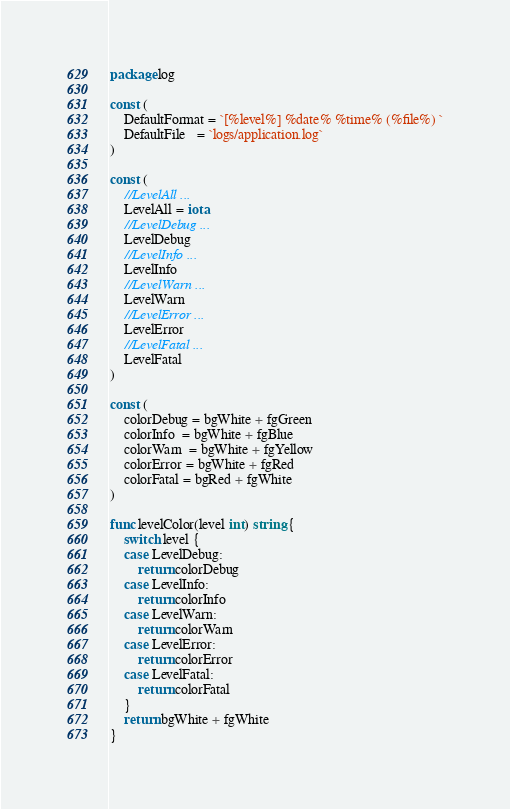Convert code to text. <code><loc_0><loc_0><loc_500><loc_500><_Go_>package log

const (
	DefaultFormat = `[%level%] %date% %time% (%file%) `
	DefaultFile   = `logs/application.log`
)

const (
	//LevelAll ...
	LevelAll = iota
	//LevelDebug ...
	LevelDebug
	//LevelInfo ...
	LevelInfo
	//LevelWarn ...
	LevelWarn
	//LevelError ...
	LevelError
	//LevelFatal ...
	LevelFatal
)

const (
	colorDebug = bgWhite + fgGreen
	colorInfo  = bgWhite + fgBlue
	colorWarn  = bgWhite + fgYellow
	colorError = bgWhite + fgRed
	colorFatal = bgRed + fgWhite
)

func levelColor(level int) string {
	switch level {
	case LevelDebug:
		return colorDebug
	case LevelInfo:
		return colorInfo
	case LevelWarn:
		return colorWarn
	case LevelError:
		return colorError
	case LevelFatal:
		return colorFatal
	}
	return bgWhite + fgWhite
}
</code> 